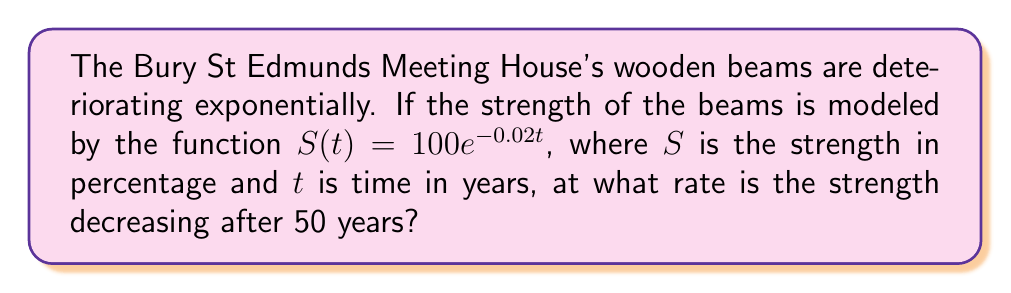Can you solve this math problem? To find the rate of decrease in strength after 50 years, we need to find the derivative of the strength function and evaluate it at $t=50$.

Step 1: Find the derivative of $S(t)$.
$$\frac{d}{dt}S(t) = \frac{d}{dt}(100e^{-0.02t})$$
$$S'(t) = 100 \cdot (-0.02)e^{-0.02t}$$
$$S'(t) = -2e^{-0.02t}$$

Step 2: Evaluate $S'(t)$ at $t=50$.
$$S'(50) = -2e^{-0.02(50)}$$
$$S'(50) = -2e^{-1}$$
$$S'(50) \approx -0.7358$$

The negative sign indicates that the strength is decreasing. The rate of decrease is approximately 0.7358% per year after 50 years.
Answer: $-0.7358\%$ per year 